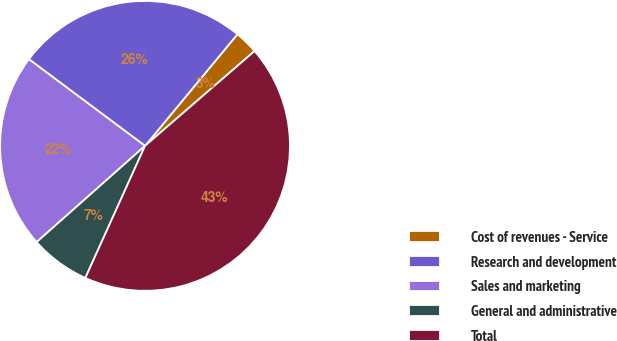<chart> <loc_0><loc_0><loc_500><loc_500><pie_chart><fcel>Cost of revenues - Service<fcel>Research and development<fcel>Sales and marketing<fcel>General and administrative<fcel>Total<nl><fcel>2.64%<fcel>25.8%<fcel>21.76%<fcel>6.69%<fcel>43.11%<nl></chart> 